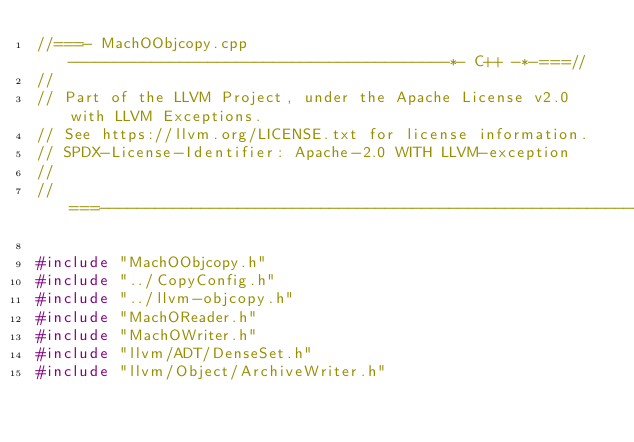<code> <loc_0><loc_0><loc_500><loc_500><_C++_>//===- MachOObjcopy.cpp -----------------------------------------*- C++ -*-===//
//
// Part of the LLVM Project, under the Apache License v2.0 with LLVM Exceptions.
// See https://llvm.org/LICENSE.txt for license information.
// SPDX-License-Identifier: Apache-2.0 WITH LLVM-exception
//
//===----------------------------------------------------------------------===//

#include "MachOObjcopy.h"
#include "../CopyConfig.h"
#include "../llvm-objcopy.h"
#include "MachOReader.h"
#include "MachOWriter.h"
#include "llvm/ADT/DenseSet.h"
#include "llvm/Object/ArchiveWriter.h"</code> 